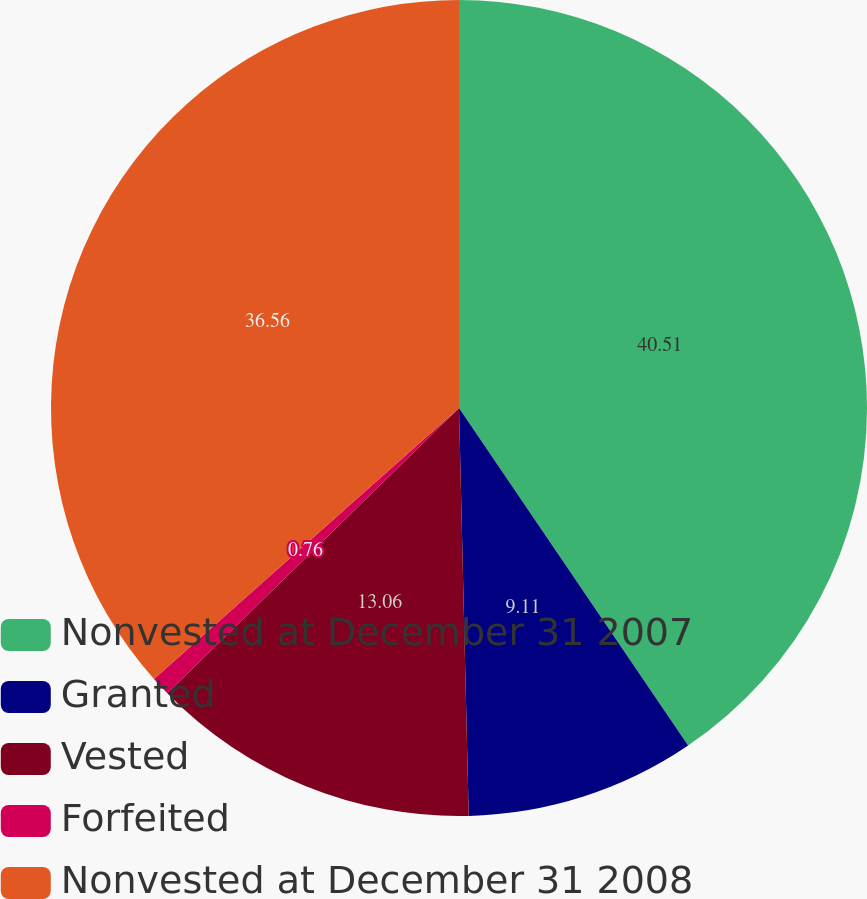<chart> <loc_0><loc_0><loc_500><loc_500><pie_chart><fcel>Nonvested at December 31 2007<fcel>Granted<fcel>Vested<fcel>Forfeited<fcel>Nonvested at December 31 2008<nl><fcel>40.51%<fcel>9.11%<fcel>13.06%<fcel>0.76%<fcel>36.56%<nl></chart> 